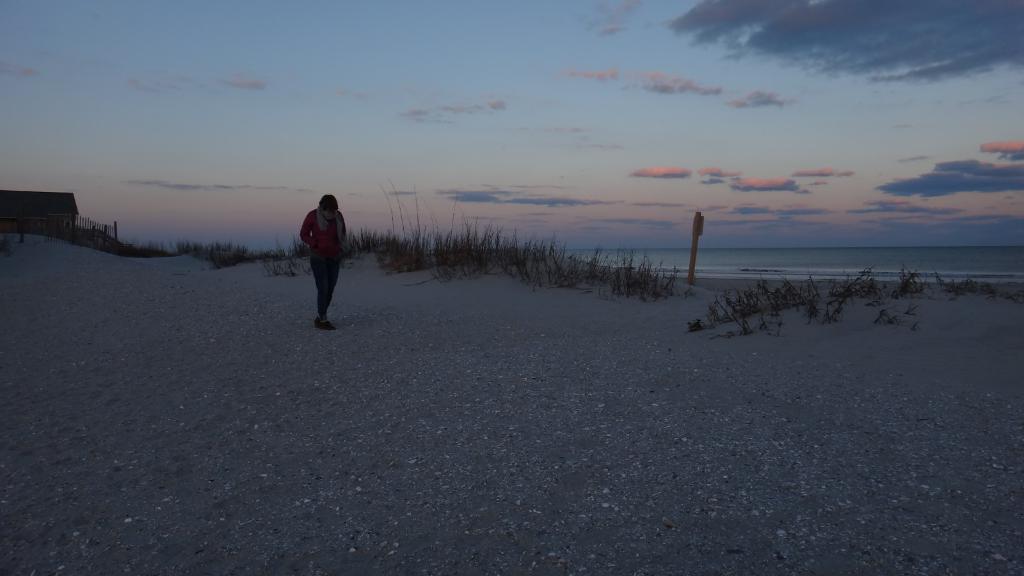Could you give a brief overview of what you see in this image? Here is a person standing. This is the grass. I can see a house. I think this is the seashore. Here is a pole. This looks like water. These are the clouds in the sky. 